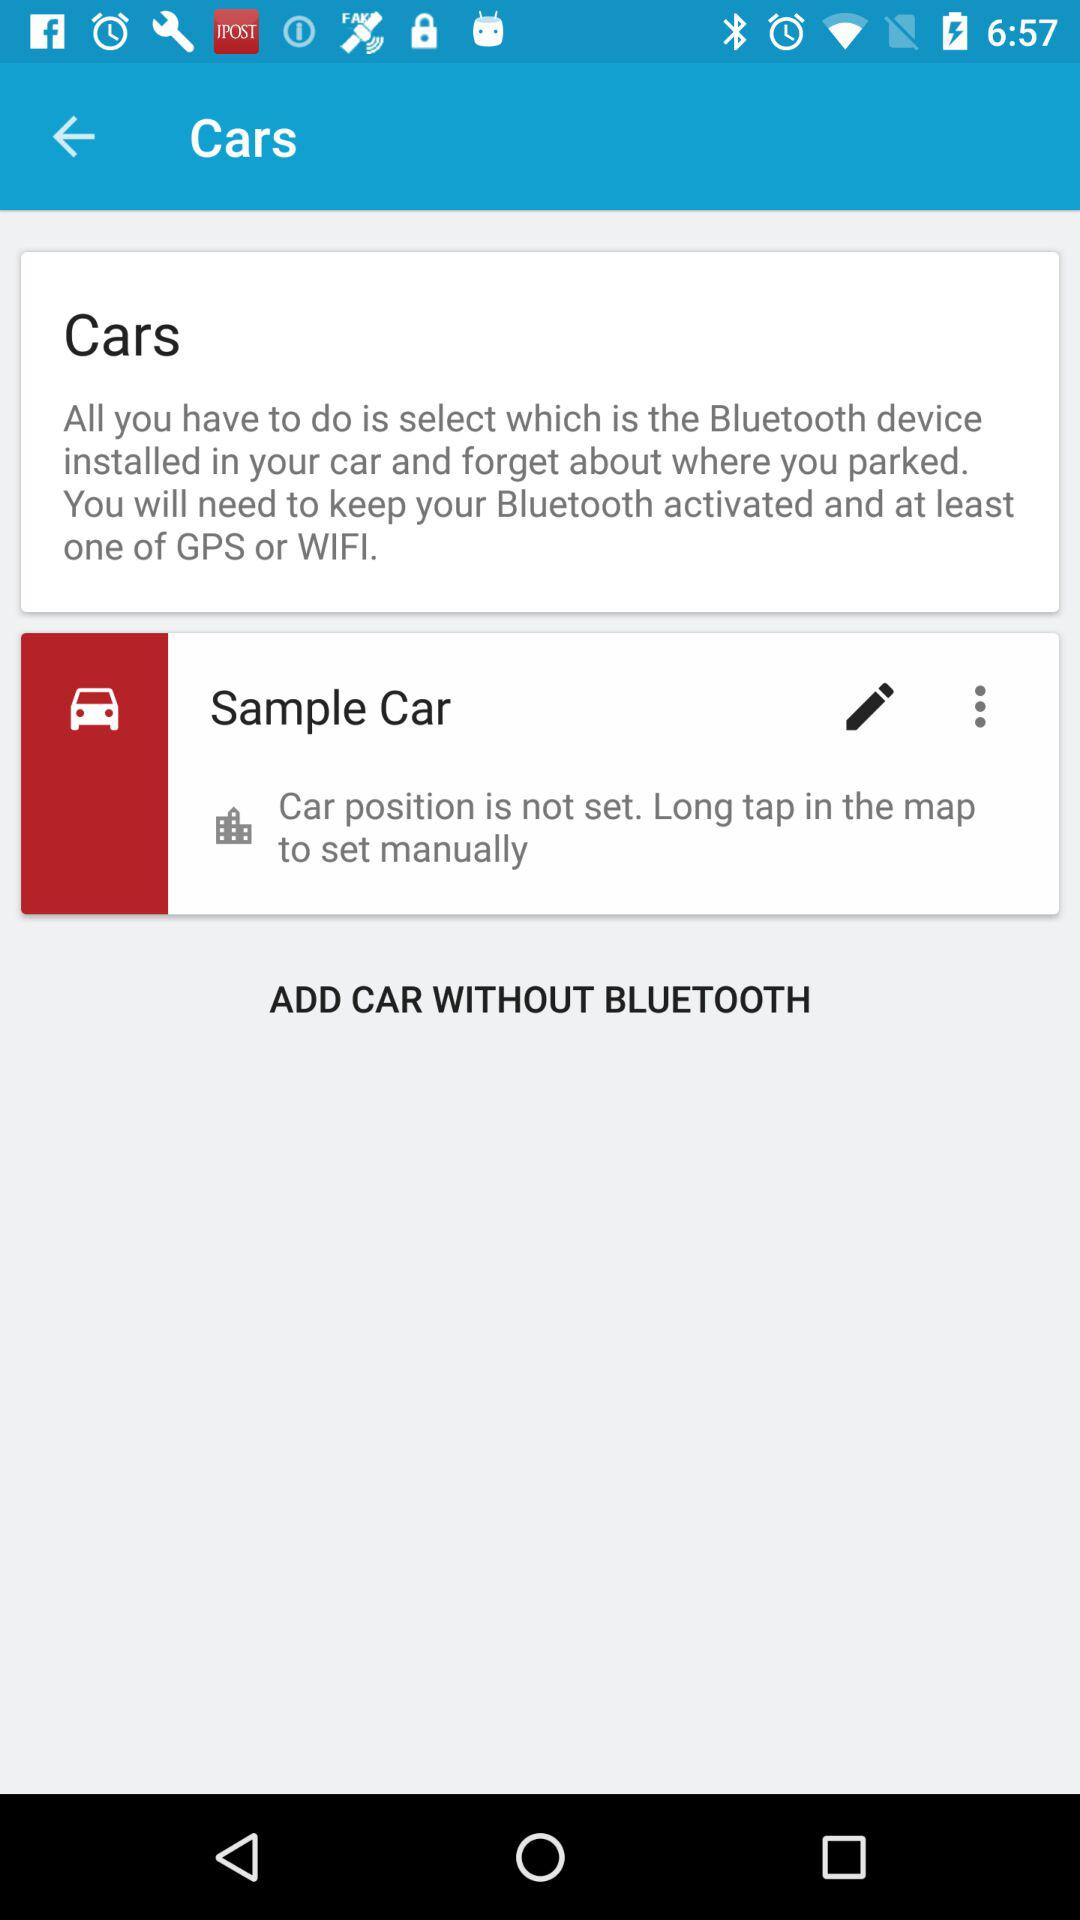Is the car position set in the sample car? The car position is not set. 